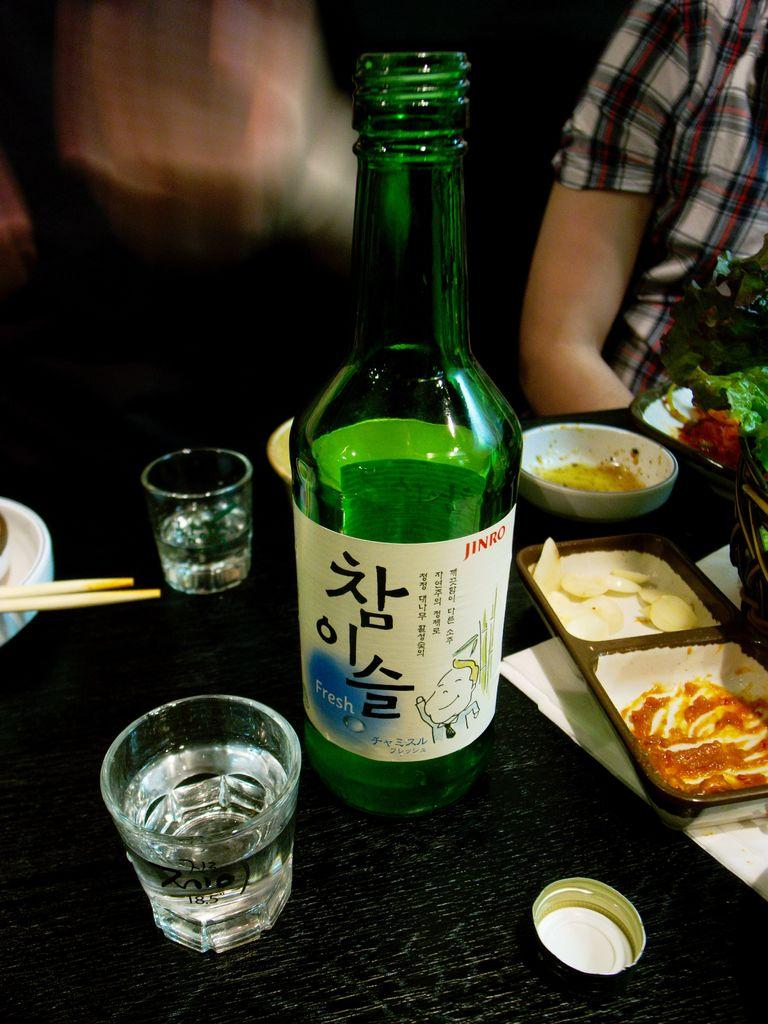<image>
Describe the image concisely. A bottled beverage, labelled Jinro, is on a table amidst shot glasses and food. 